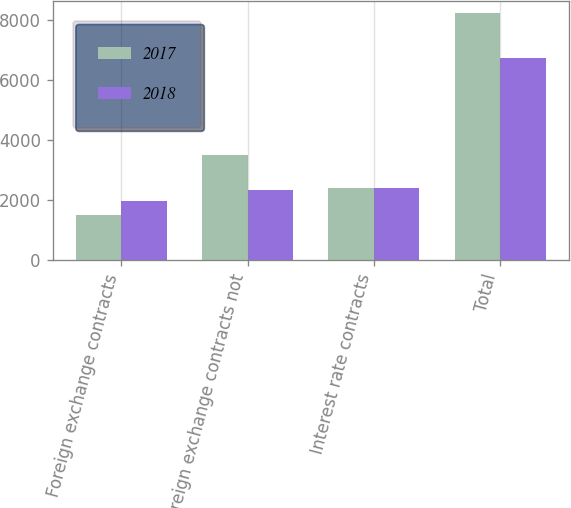Convert chart. <chart><loc_0><loc_0><loc_500><loc_500><stacked_bar_chart><ecel><fcel>Foreign exchange contracts<fcel>Foreign exchange contracts not<fcel>Interest rate contracts<fcel>Total<nl><fcel>2017<fcel>1510<fcel>3517<fcel>2400<fcel>8231<nl><fcel>2018<fcel>1990<fcel>2349<fcel>2400<fcel>6739<nl></chart> 